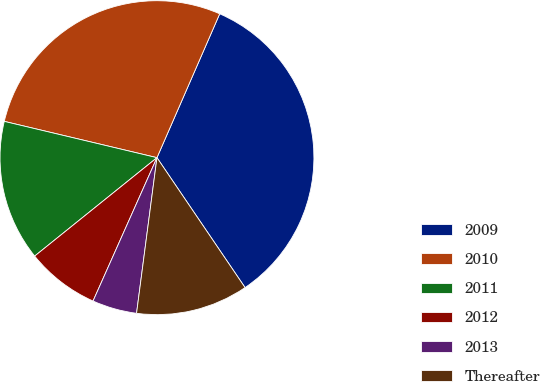Convert chart. <chart><loc_0><loc_0><loc_500><loc_500><pie_chart><fcel>2009<fcel>2010<fcel>2011<fcel>2012<fcel>2013<fcel>Thereafter<nl><fcel>33.97%<fcel>27.83%<fcel>14.5%<fcel>7.54%<fcel>4.6%<fcel>11.56%<nl></chart> 